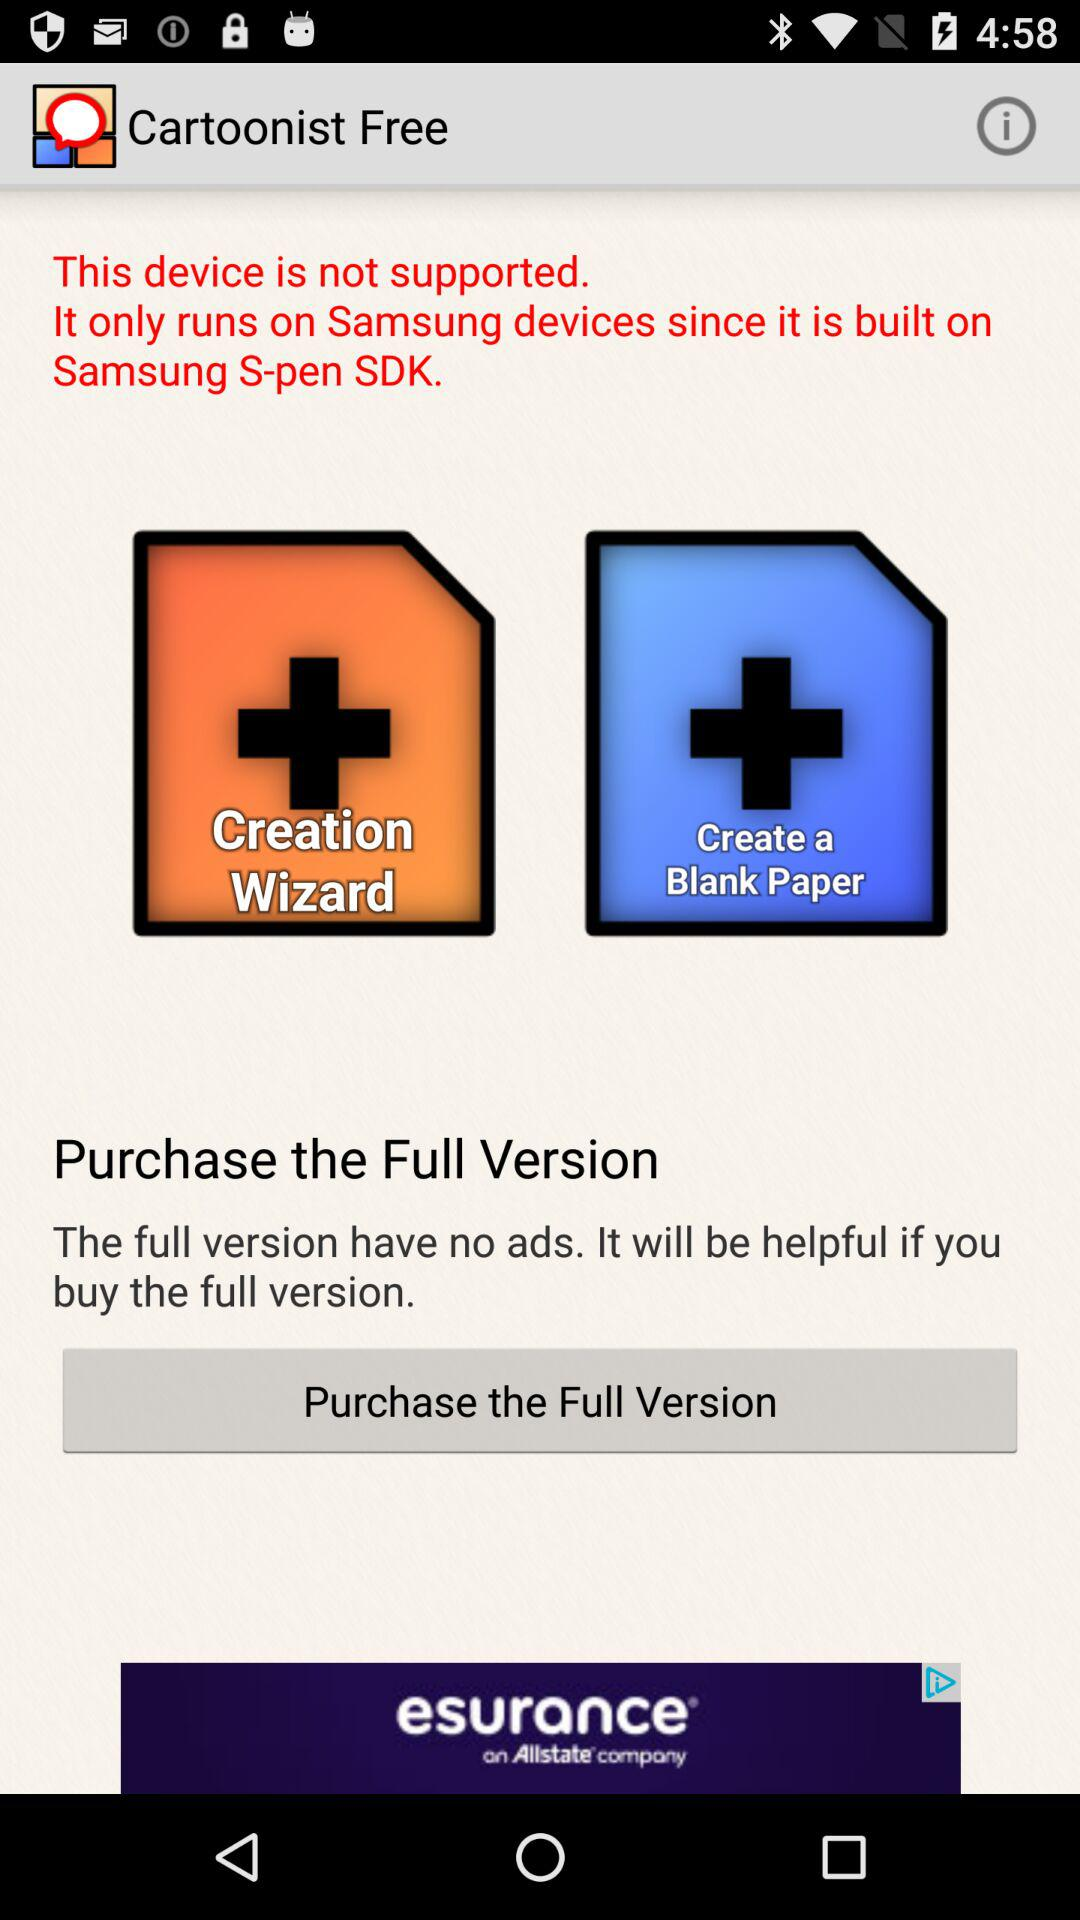On which devices will the application only run? The application will only run on Samsung devices. 